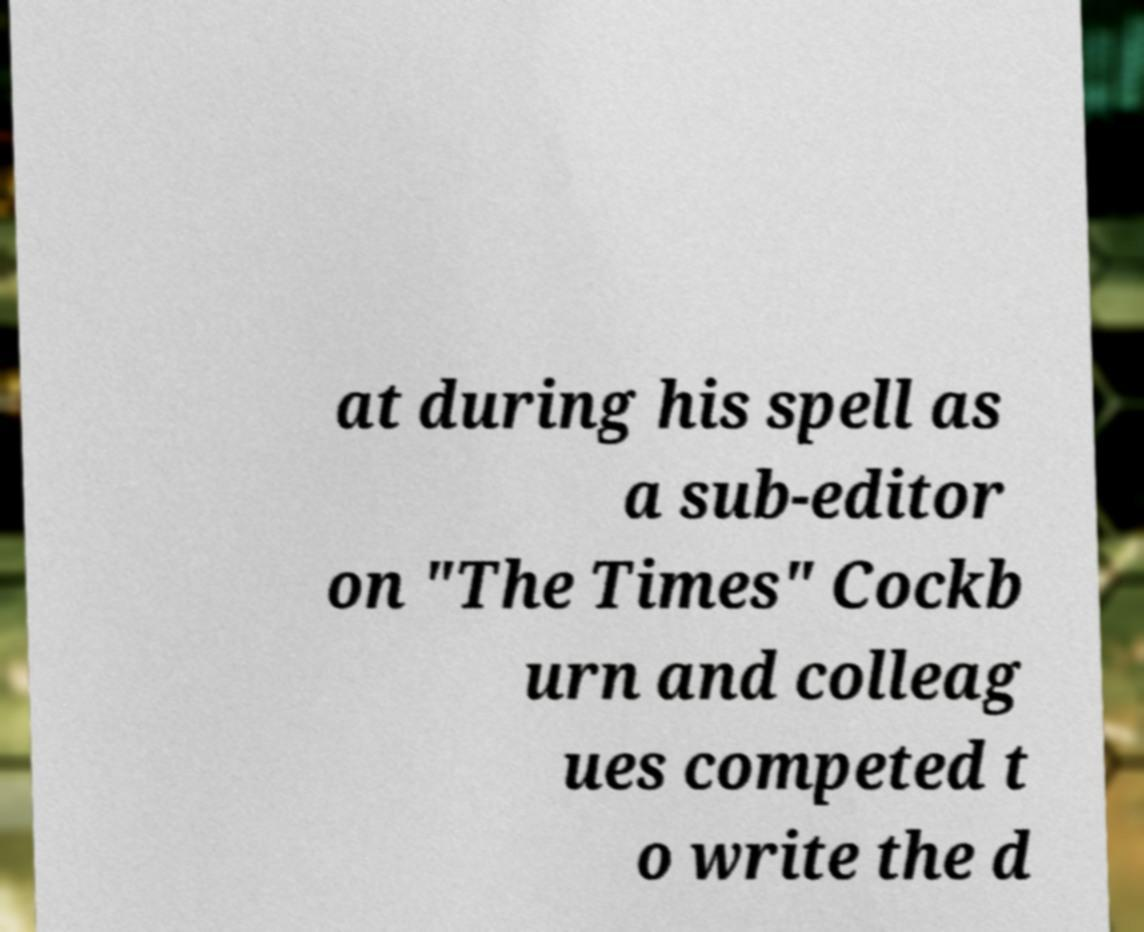Can you read and provide the text displayed in the image?This photo seems to have some interesting text. Can you extract and type it out for me? at during his spell as a sub-editor on "The Times" Cockb urn and colleag ues competed t o write the d 